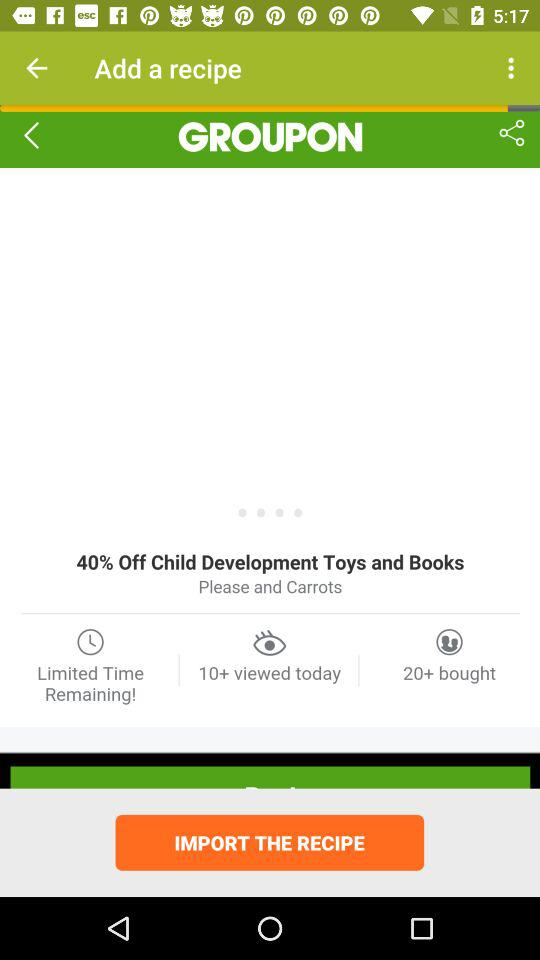How many people have viewed "GROUPON" today? Today, more than ten people have viewed "GROUPON". 